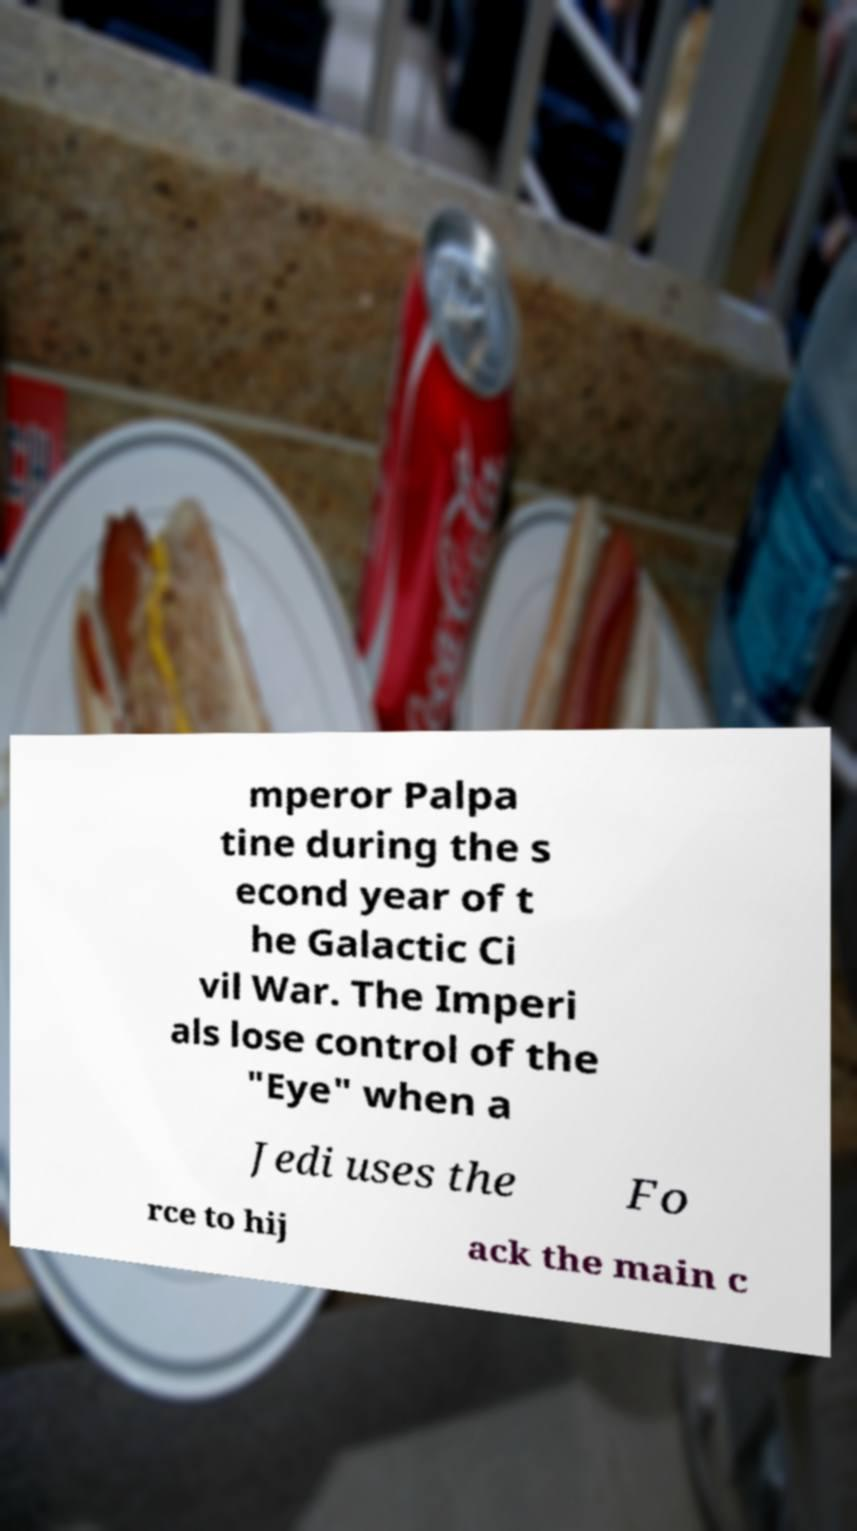Please identify and transcribe the text found in this image. mperor Palpa tine during the s econd year of t he Galactic Ci vil War. The Imperi als lose control of the "Eye" when a Jedi uses the Fo rce to hij ack the main c 